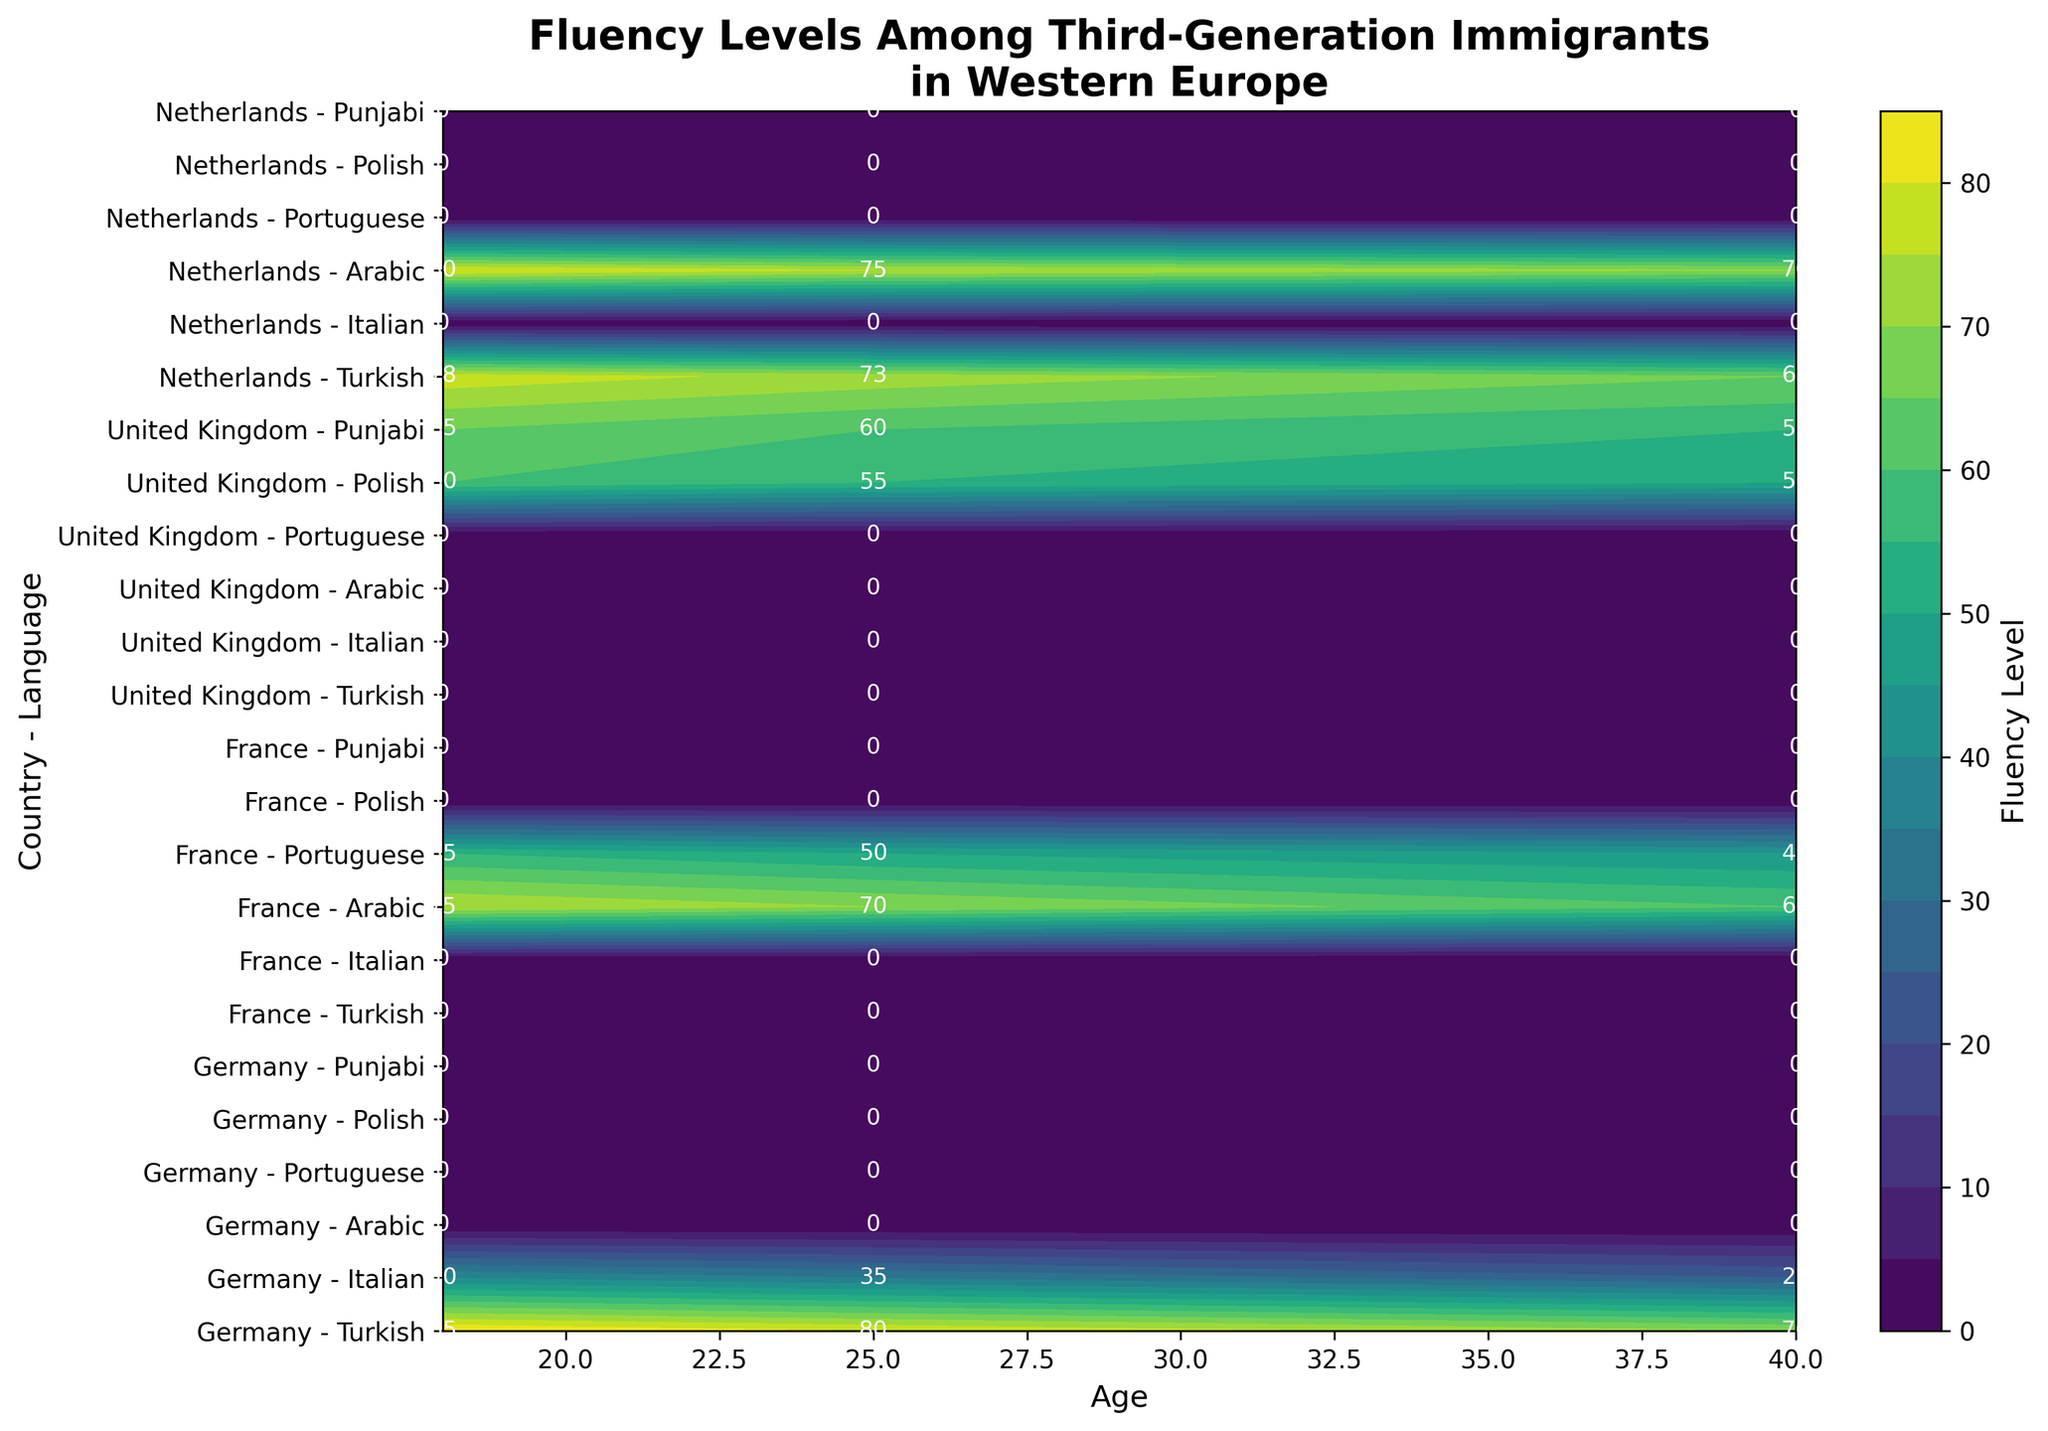What is the title of the figure? The title of the figure is located at the top and is usually written in a larger and bold font. It provides a summary of what the figure represents.
Answer: Fluency Levels Among Third-Generation Immigrants in Western Europe Which country-language combination has the highest fluency level among 18-year-olds? By inspecting the contours and the annotations on the plot, we can identify the data point with the highest value at the age of 18.
Answer: Germany - Turkish How does the fluency level of Turkish speakers in Germany change with age? We need to observe the contour levels for the Turkish-Germany combination across different ages (18, 25, 40) as annotated on the plot.
Answer: It decreases from 85 to 70 For which country and language is the fluency level the lowest at age 40? Reviewing the contour labels for 40-year-olds across all country-language combinations, we find the smallest value.
Answer: Germany - Italian Is the fluency level higher for French-Arabic speakers or French-Portuguese speakers at age 25? Compare the contour values for both French-Arabic and French-Portuguese at the age of 25 by looking at the annotations.
Answer: French-Arabic Between Punjabi speakers in the United Kingdom and Turkish speakers in the Netherlands, who has a higher fluency level at age 18? Look at the contour annotations for both Punjabi-United Kingdom and Turkish-Netherlands at age 18.
Answer: Turkish speakers in the Netherlands How do the fluency levels of Arabic speakers compare in France and the Netherlands at age 40? Check the contour values for Arabic speakers in both France and the Netherlands at age 40, and compare them.
Answer: 60 (France) vs 70 (Netherlands); Netherlands is higher At what age do Turkish speakers in the Netherlands show the highest fluency level? Examine the contour levels annotated for Turkish speakers in the Netherlands across ages 18, 25, and 40.
Answer: 18 What is the overall trend of fluency levels with increasing age for immigrants in Western Europe? Consider the general pattern shown by the contour levels and annotations for all country-language groups from ages 18 to 40.
Answer: Generally decreasing 